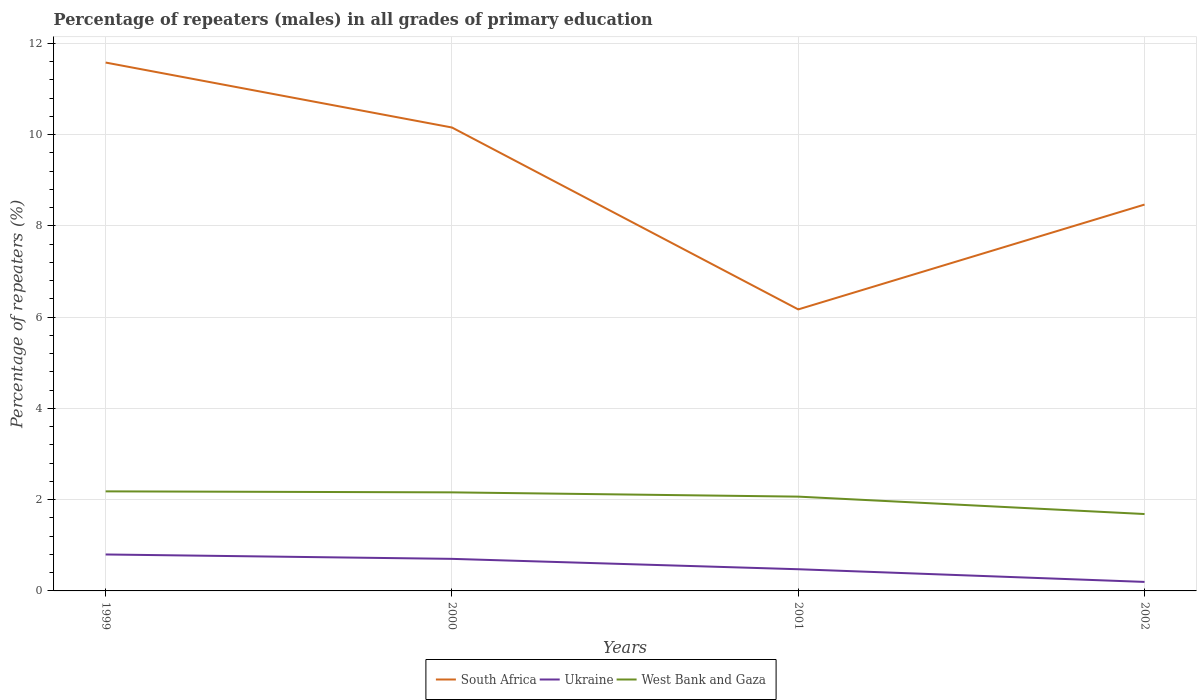Across all years, what is the maximum percentage of repeaters (males) in South Africa?
Keep it short and to the point. 6.17. In which year was the percentage of repeaters (males) in West Bank and Gaza maximum?
Provide a succinct answer. 2002. What is the total percentage of repeaters (males) in South Africa in the graph?
Give a very brief answer. 1.69. What is the difference between the highest and the second highest percentage of repeaters (males) in West Bank and Gaza?
Make the answer very short. 0.5. How many lines are there?
Your answer should be compact. 3. How many years are there in the graph?
Offer a very short reply. 4. Does the graph contain grids?
Ensure brevity in your answer.  Yes. How many legend labels are there?
Give a very brief answer. 3. What is the title of the graph?
Ensure brevity in your answer.  Percentage of repeaters (males) in all grades of primary education. What is the label or title of the X-axis?
Ensure brevity in your answer.  Years. What is the label or title of the Y-axis?
Give a very brief answer. Percentage of repeaters (%). What is the Percentage of repeaters (%) of South Africa in 1999?
Your answer should be compact. 11.58. What is the Percentage of repeaters (%) of Ukraine in 1999?
Offer a very short reply. 0.8. What is the Percentage of repeaters (%) of West Bank and Gaza in 1999?
Your answer should be very brief. 2.18. What is the Percentage of repeaters (%) of South Africa in 2000?
Keep it short and to the point. 10.16. What is the Percentage of repeaters (%) of Ukraine in 2000?
Provide a short and direct response. 0.7. What is the Percentage of repeaters (%) in West Bank and Gaza in 2000?
Offer a terse response. 2.16. What is the Percentage of repeaters (%) of South Africa in 2001?
Your answer should be compact. 6.17. What is the Percentage of repeaters (%) in Ukraine in 2001?
Provide a short and direct response. 0.48. What is the Percentage of repeaters (%) in West Bank and Gaza in 2001?
Your answer should be compact. 2.07. What is the Percentage of repeaters (%) in South Africa in 2002?
Provide a short and direct response. 8.47. What is the Percentage of repeaters (%) of Ukraine in 2002?
Offer a terse response. 0.2. What is the Percentage of repeaters (%) of West Bank and Gaza in 2002?
Ensure brevity in your answer.  1.68. Across all years, what is the maximum Percentage of repeaters (%) of South Africa?
Give a very brief answer. 11.58. Across all years, what is the maximum Percentage of repeaters (%) in Ukraine?
Make the answer very short. 0.8. Across all years, what is the maximum Percentage of repeaters (%) in West Bank and Gaza?
Keep it short and to the point. 2.18. Across all years, what is the minimum Percentage of repeaters (%) of South Africa?
Your answer should be very brief. 6.17. Across all years, what is the minimum Percentage of repeaters (%) in Ukraine?
Keep it short and to the point. 0.2. Across all years, what is the minimum Percentage of repeaters (%) of West Bank and Gaza?
Your response must be concise. 1.68. What is the total Percentage of repeaters (%) in South Africa in the graph?
Provide a short and direct response. 36.37. What is the total Percentage of repeaters (%) in Ukraine in the graph?
Ensure brevity in your answer.  2.17. What is the total Percentage of repeaters (%) in West Bank and Gaza in the graph?
Provide a short and direct response. 8.09. What is the difference between the Percentage of repeaters (%) of South Africa in 1999 and that in 2000?
Provide a short and direct response. 1.42. What is the difference between the Percentage of repeaters (%) in Ukraine in 1999 and that in 2000?
Make the answer very short. 0.1. What is the difference between the Percentage of repeaters (%) in West Bank and Gaza in 1999 and that in 2000?
Your response must be concise. 0.02. What is the difference between the Percentage of repeaters (%) in South Africa in 1999 and that in 2001?
Provide a succinct answer. 5.41. What is the difference between the Percentage of repeaters (%) in Ukraine in 1999 and that in 2001?
Give a very brief answer. 0.32. What is the difference between the Percentage of repeaters (%) of West Bank and Gaza in 1999 and that in 2001?
Your response must be concise. 0.12. What is the difference between the Percentage of repeaters (%) of South Africa in 1999 and that in 2002?
Provide a succinct answer. 3.11. What is the difference between the Percentage of repeaters (%) in Ukraine in 1999 and that in 2002?
Your answer should be compact. 0.6. What is the difference between the Percentage of repeaters (%) of West Bank and Gaza in 1999 and that in 2002?
Keep it short and to the point. 0.5. What is the difference between the Percentage of repeaters (%) in South Africa in 2000 and that in 2001?
Offer a very short reply. 3.99. What is the difference between the Percentage of repeaters (%) in Ukraine in 2000 and that in 2001?
Provide a succinct answer. 0.23. What is the difference between the Percentage of repeaters (%) of West Bank and Gaza in 2000 and that in 2001?
Your answer should be compact. 0.09. What is the difference between the Percentage of repeaters (%) in South Africa in 2000 and that in 2002?
Your answer should be very brief. 1.69. What is the difference between the Percentage of repeaters (%) in Ukraine in 2000 and that in 2002?
Your answer should be very brief. 0.51. What is the difference between the Percentage of repeaters (%) in West Bank and Gaza in 2000 and that in 2002?
Make the answer very short. 0.47. What is the difference between the Percentage of repeaters (%) of South Africa in 2001 and that in 2002?
Offer a terse response. -2.3. What is the difference between the Percentage of repeaters (%) in Ukraine in 2001 and that in 2002?
Make the answer very short. 0.28. What is the difference between the Percentage of repeaters (%) of West Bank and Gaza in 2001 and that in 2002?
Make the answer very short. 0.38. What is the difference between the Percentage of repeaters (%) of South Africa in 1999 and the Percentage of repeaters (%) of Ukraine in 2000?
Offer a terse response. 10.88. What is the difference between the Percentage of repeaters (%) of South Africa in 1999 and the Percentage of repeaters (%) of West Bank and Gaza in 2000?
Your response must be concise. 9.42. What is the difference between the Percentage of repeaters (%) of Ukraine in 1999 and the Percentage of repeaters (%) of West Bank and Gaza in 2000?
Give a very brief answer. -1.36. What is the difference between the Percentage of repeaters (%) in South Africa in 1999 and the Percentage of repeaters (%) in Ukraine in 2001?
Provide a short and direct response. 11.1. What is the difference between the Percentage of repeaters (%) in South Africa in 1999 and the Percentage of repeaters (%) in West Bank and Gaza in 2001?
Give a very brief answer. 9.51. What is the difference between the Percentage of repeaters (%) of Ukraine in 1999 and the Percentage of repeaters (%) of West Bank and Gaza in 2001?
Offer a very short reply. -1.27. What is the difference between the Percentage of repeaters (%) of South Africa in 1999 and the Percentage of repeaters (%) of Ukraine in 2002?
Provide a short and direct response. 11.38. What is the difference between the Percentage of repeaters (%) of South Africa in 1999 and the Percentage of repeaters (%) of West Bank and Gaza in 2002?
Your answer should be very brief. 9.89. What is the difference between the Percentage of repeaters (%) in Ukraine in 1999 and the Percentage of repeaters (%) in West Bank and Gaza in 2002?
Your answer should be very brief. -0.89. What is the difference between the Percentage of repeaters (%) of South Africa in 2000 and the Percentage of repeaters (%) of Ukraine in 2001?
Your answer should be compact. 9.68. What is the difference between the Percentage of repeaters (%) in South Africa in 2000 and the Percentage of repeaters (%) in West Bank and Gaza in 2001?
Provide a short and direct response. 8.09. What is the difference between the Percentage of repeaters (%) of Ukraine in 2000 and the Percentage of repeaters (%) of West Bank and Gaza in 2001?
Offer a very short reply. -1.36. What is the difference between the Percentage of repeaters (%) of South Africa in 2000 and the Percentage of repeaters (%) of Ukraine in 2002?
Offer a very short reply. 9.96. What is the difference between the Percentage of repeaters (%) of South Africa in 2000 and the Percentage of repeaters (%) of West Bank and Gaza in 2002?
Make the answer very short. 8.47. What is the difference between the Percentage of repeaters (%) of Ukraine in 2000 and the Percentage of repeaters (%) of West Bank and Gaza in 2002?
Offer a very short reply. -0.98. What is the difference between the Percentage of repeaters (%) in South Africa in 2001 and the Percentage of repeaters (%) in Ukraine in 2002?
Keep it short and to the point. 5.97. What is the difference between the Percentage of repeaters (%) in South Africa in 2001 and the Percentage of repeaters (%) in West Bank and Gaza in 2002?
Your answer should be compact. 4.48. What is the difference between the Percentage of repeaters (%) in Ukraine in 2001 and the Percentage of repeaters (%) in West Bank and Gaza in 2002?
Offer a terse response. -1.21. What is the average Percentage of repeaters (%) in South Africa per year?
Provide a short and direct response. 9.09. What is the average Percentage of repeaters (%) in Ukraine per year?
Ensure brevity in your answer.  0.54. What is the average Percentage of repeaters (%) in West Bank and Gaza per year?
Keep it short and to the point. 2.02. In the year 1999, what is the difference between the Percentage of repeaters (%) of South Africa and Percentage of repeaters (%) of Ukraine?
Offer a very short reply. 10.78. In the year 1999, what is the difference between the Percentage of repeaters (%) of South Africa and Percentage of repeaters (%) of West Bank and Gaza?
Provide a succinct answer. 9.4. In the year 1999, what is the difference between the Percentage of repeaters (%) of Ukraine and Percentage of repeaters (%) of West Bank and Gaza?
Give a very brief answer. -1.38. In the year 2000, what is the difference between the Percentage of repeaters (%) of South Africa and Percentage of repeaters (%) of Ukraine?
Your response must be concise. 9.45. In the year 2000, what is the difference between the Percentage of repeaters (%) of South Africa and Percentage of repeaters (%) of West Bank and Gaza?
Give a very brief answer. 8. In the year 2000, what is the difference between the Percentage of repeaters (%) in Ukraine and Percentage of repeaters (%) in West Bank and Gaza?
Provide a short and direct response. -1.46. In the year 2001, what is the difference between the Percentage of repeaters (%) in South Africa and Percentage of repeaters (%) in Ukraine?
Ensure brevity in your answer.  5.69. In the year 2001, what is the difference between the Percentage of repeaters (%) of South Africa and Percentage of repeaters (%) of West Bank and Gaza?
Make the answer very short. 4.1. In the year 2001, what is the difference between the Percentage of repeaters (%) in Ukraine and Percentage of repeaters (%) in West Bank and Gaza?
Your answer should be compact. -1.59. In the year 2002, what is the difference between the Percentage of repeaters (%) of South Africa and Percentage of repeaters (%) of Ukraine?
Keep it short and to the point. 8.27. In the year 2002, what is the difference between the Percentage of repeaters (%) in South Africa and Percentage of repeaters (%) in West Bank and Gaza?
Make the answer very short. 6.78. In the year 2002, what is the difference between the Percentage of repeaters (%) in Ukraine and Percentage of repeaters (%) in West Bank and Gaza?
Your answer should be very brief. -1.49. What is the ratio of the Percentage of repeaters (%) of South Africa in 1999 to that in 2000?
Your answer should be very brief. 1.14. What is the ratio of the Percentage of repeaters (%) in Ukraine in 1999 to that in 2000?
Provide a short and direct response. 1.14. What is the ratio of the Percentage of repeaters (%) in West Bank and Gaza in 1999 to that in 2000?
Give a very brief answer. 1.01. What is the ratio of the Percentage of repeaters (%) in South Africa in 1999 to that in 2001?
Give a very brief answer. 1.88. What is the ratio of the Percentage of repeaters (%) in Ukraine in 1999 to that in 2001?
Your answer should be very brief. 1.68. What is the ratio of the Percentage of repeaters (%) in West Bank and Gaza in 1999 to that in 2001?
Provide a succinct answer. 1.06. What is the ratio of the Percentage of repeaters (%) in South Africa in 1999 to that in 2002?
Make the answer very short. 1.37. What is the ratio of the Percentage of repeaters (%) in Ukraine in 1999 to that in 2002?
Provide a succinct answer. 4.04. What is the ratio of the Percentage of repeaters (%) of West Bank and Gaza in 1999 to that in 2002?
Your answer should be compact. 1.29. What is the ratio of the Percentage of repeaters (%) of South Africa in 2000 to that in 2001?
Ensure brevity in your answer.  1.65. What is the ratio of the Percentage of repeaters (%) in Ukraine in 2000 to that in 2001?
Your response must be concise. 1.48. What is the ratio of the Percentage of repeaters (%) of West Bank and Gaza in 2000 to that in 2001?
Offer a very short reply. 1.05. What is the ratio of the Percentage of repeaters (%) of South Africa in 2000 to that in 2002?
Offer a very short reply. 1.2. What is the ratio of the Percentage of repeaters (%) in Ukraine in 2000 to that in 2002?
Keep it short and to the point. 3.56. What is the ratio of the Percentage of repeaters (%) in West Bank and Gaza in 2000 to that in 2002?
Keep it short and to the point. 1.28. What is the ratio of the Percentage of repeaters (%) of South Africa in 2001 to that in 2002?
Your response must be concise. 0.73. What is the ratio of the Percentage of repeaters (%) in Ukraine in 2001 to that in 2002?
Keep it short and to the point. 2.41. What is the ratio of the Percentage of repeaters (%) in West Bank and Gaza in 2001 to that in 2002?
Your answer should be compact. 1.23. What is the difference between the highest and the second highest Percentage of repeaters (%) in South Africa?
Offer a very short reply. 1.42. What is the difference between the highest and the second highest Percentage of repeaters (%) in Ukraine?
Provide a short and direct response. 0.1. What is the difference between the highest and the second highest Percentage of repeaters (%) in West Bank and Gaza?
Your answer should be compact. 0.02. What is the difference between the highest and the lowest Percentage of repeaters (%) of South Africa?
Your answer should be compact. 5.41. What is the difference between the highest and the lowest Percentage of repeaters (%) of Ukraine?
Your answer should be very brief. 0.6. What is the difference between the highest and the lowest Percentage of repeaters (%) in West Bank and Gaza?
Make the answer very short. 0.5. 